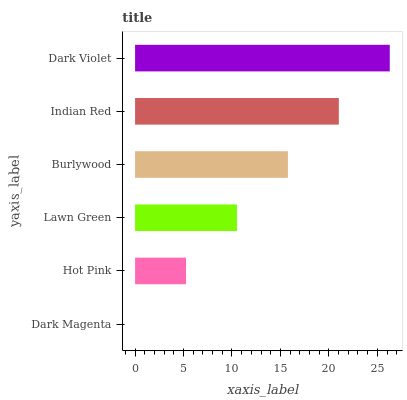Is Dark Magenta the minimum?
Answer yes or no. Yes. Is Dark Violet the maximum?
Answer yes or no. Yes. Is Hot Pink the minimum?
Answer yes or no. No. Is Hot Pink the maximum?
Answer yes or no. No. Is Hot Pink greater than Dark Magenta?
Answer yes or no. Yes. Is Dark Magenta less than Hot Pink?
Answer yes or no. Yes. Is Dark Magenta greater than Hot Pink?
Answer yes or no. No. Is Hot Pink less than Dark Magenta?
Answer yes or no. No. Is Burlywood the high median?
Answer yes or no. Yes. Is Lawn Green the low median?
Answer yes or no. Yes. Is Indian Red the high median?
Answer yes or no. No. Is Dark Magenta the low median?
Answer yes or no. No. 